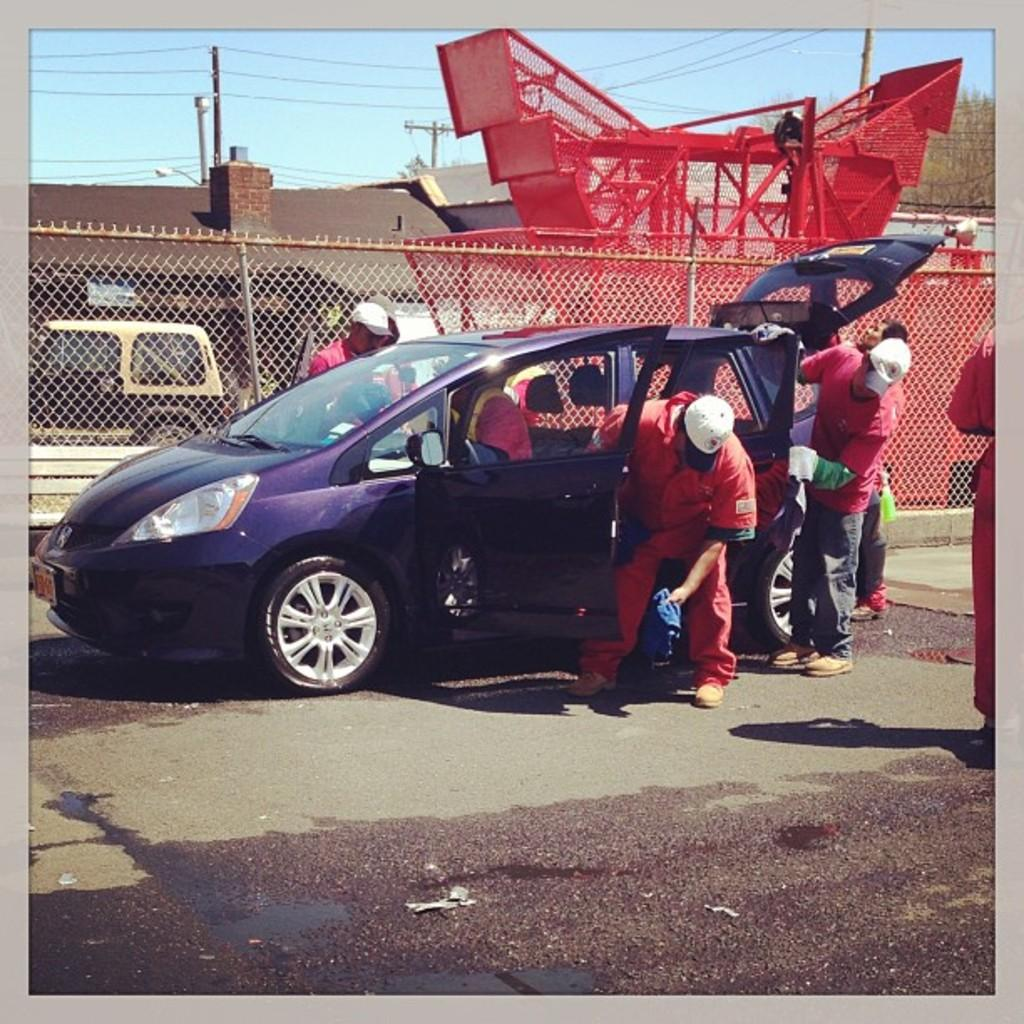What is the main subject of the image? There is a car in the center of the image. What are the people in the image doing? The people are standing around the car. What can be seen in the background of the image? The sky, a fence, a tree, a roof, a building, and a vehicle are visible in the background of the image. What type of trail can be seen in the image? There is no trail present in the image. Which direction is the car facing in the image? The facts provided do not specify the direction the car is facing. 